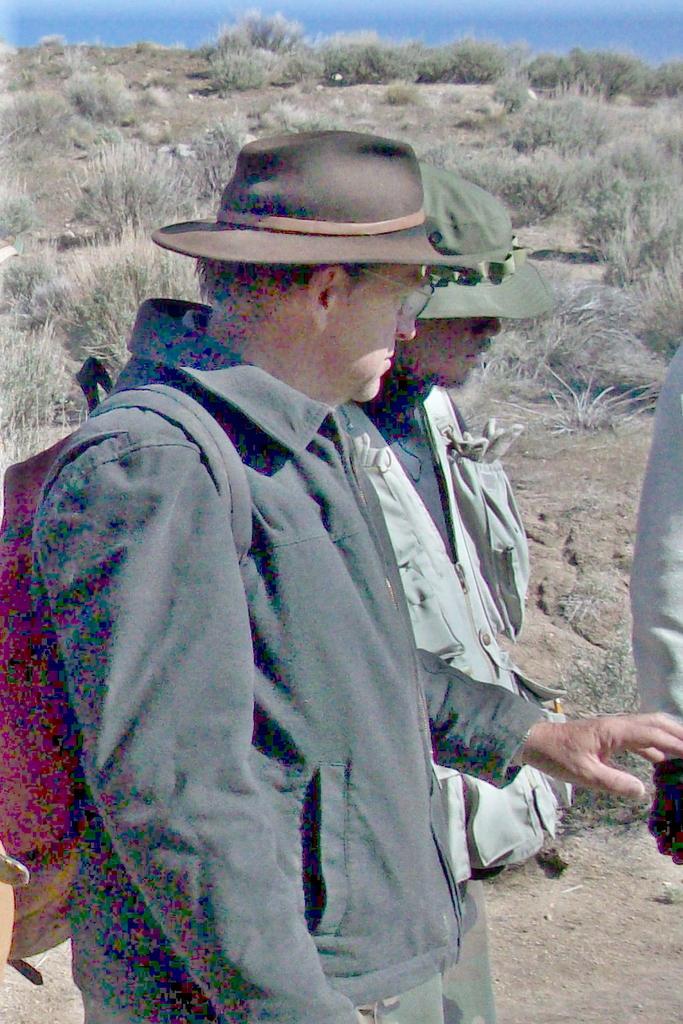In one or two sentences, can you explain what this image depicts? There are two men standing. These are the bushes. On the right side of the image, I can see a person's hand. This man wore a backpack bag. 